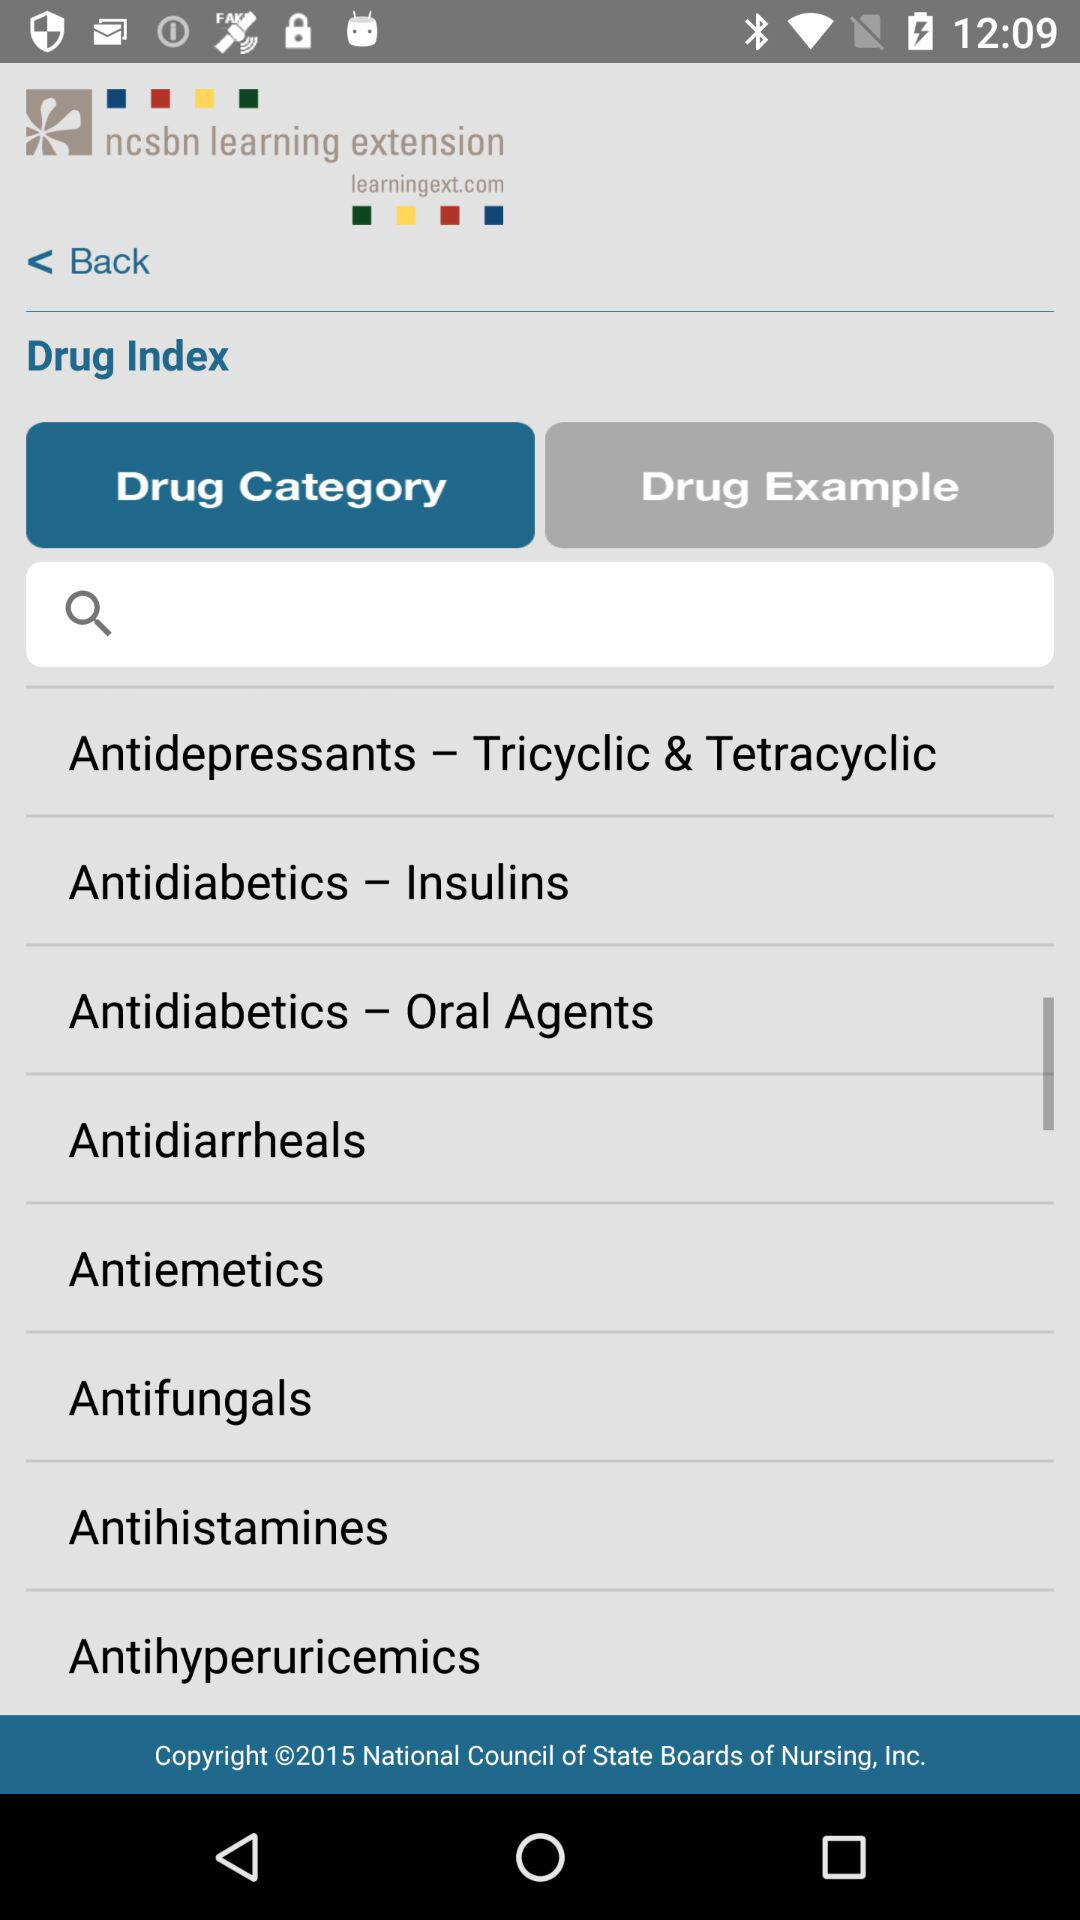Which tab is selected? The selected tab is "Drug Category". 